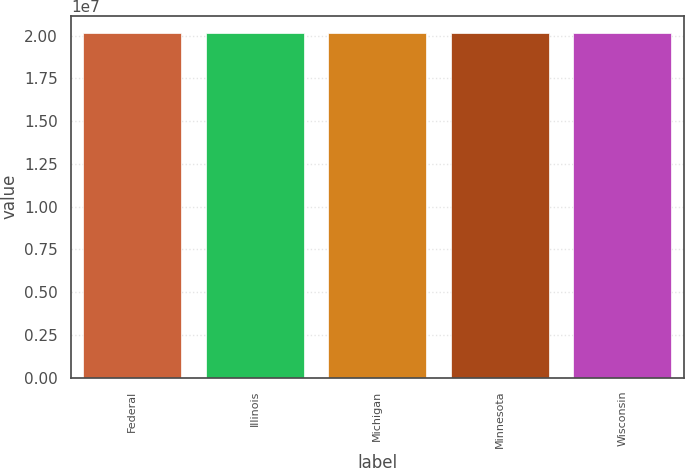Convert chart to OTSL. <chart><loc_0><loc_0><loc_500><loc_500><bar_chart><fcel>Federal<fcel>Illinois<fcel>Michigan<fcel>Minnesota<fcel>Wisconsin<nl><fcel>2.0142e+07<fcel>2.0132e+07<fcel>2.0133e+07<fcel>2.0143e+07<fcel>2.0134e+07<nl></chart> 